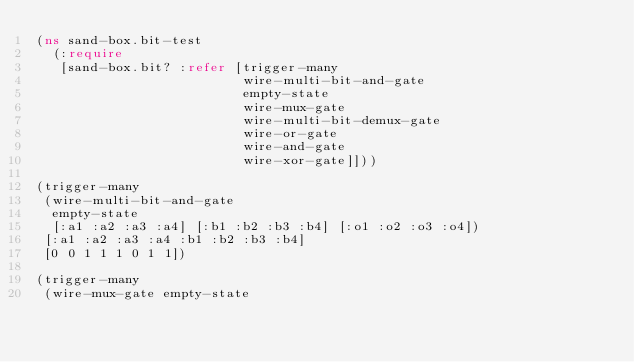<code> <loc_0><loc_0><loc_500><loc_500><_Clojure_>(ns sand-box.bit-test
  (:require 
   [sand-box.bit? :refer [trigger-many
                          wire-multi-bit-and-gate
                          empty-state
                          wire-mux-gate
                          wire-multi-bit-demux-gate
                          wire-or-gate
                          wire-and-gate
                          wire-xor-gate]]))

(trigger-many
 (wire-multi-bit-and-gate
  empty-state
  [:a1 :a2 :a3 :a4] [:b1 :b2 :b3 :b4] [:o1 :o2 :o3 :o4])
 [:a1 :a2 :a3 :a4 :b1 :b2 :b3 :b4]
 [0 0 1 1 1 0 1 1])

(trigger-many
 (wire-mux-gate empty-state</code> 